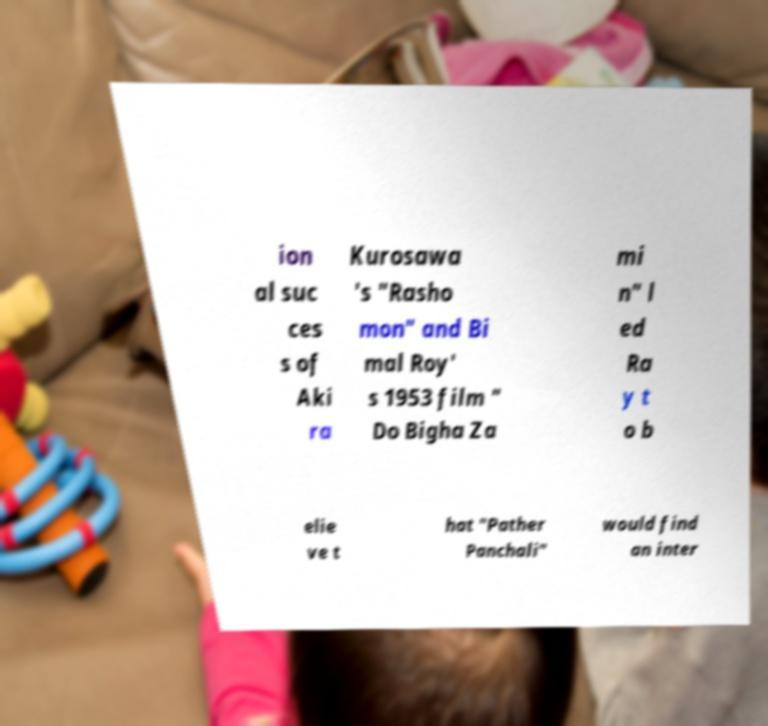Can you read and provide the text displayed in the image?This photo seems to have some interesting text. Can you extract and type it out for me? ion al suc ces s of Aki ra Kurosawa 's "Rasho mon" and Bi mal Roy' s 1953 film " Do Bigha Za mi n" l ed Ra y t o b elie ve t hat "Pather Panchali" would find an inter 